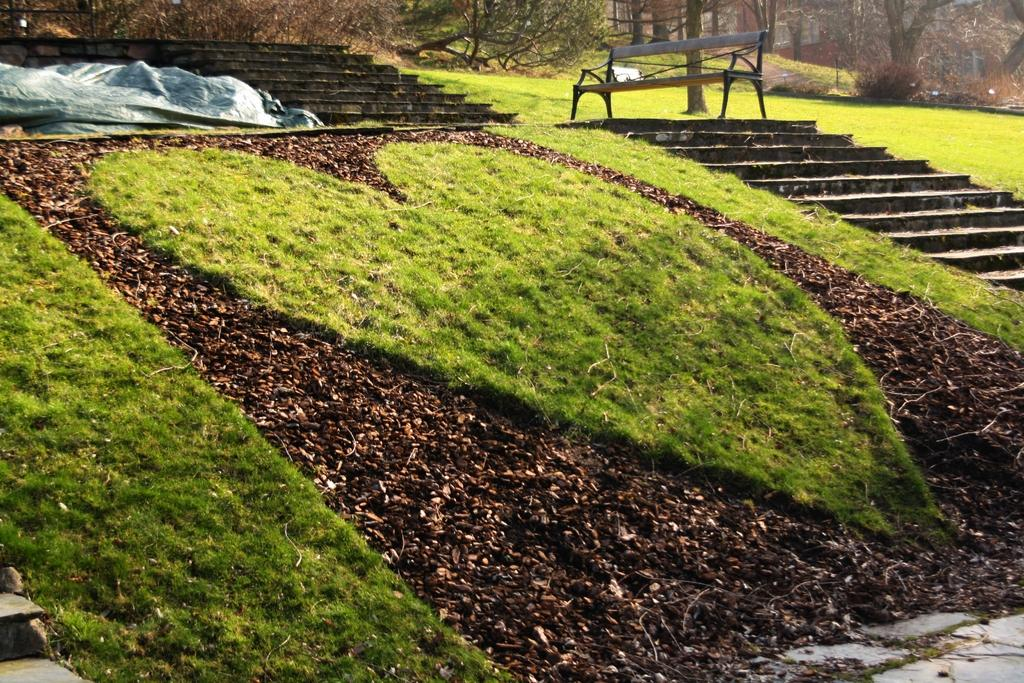What type of area is depicted in the image? There is a small garden in the image. What is unique about the grass in the garden? The grass in the garden has a heart shape. What architectural feature is located beside the garden? There are steps beside the garden. What type of seating is available in the image? There is a wooden bench in the image. What can be seen in the background of the image? Dry trees are present in the background of the image. What is the kitty thinking while sitting on the wooden bench in the image? There is no kitty present in the image, so it is not possible to determine what the kitty might be thinking. 